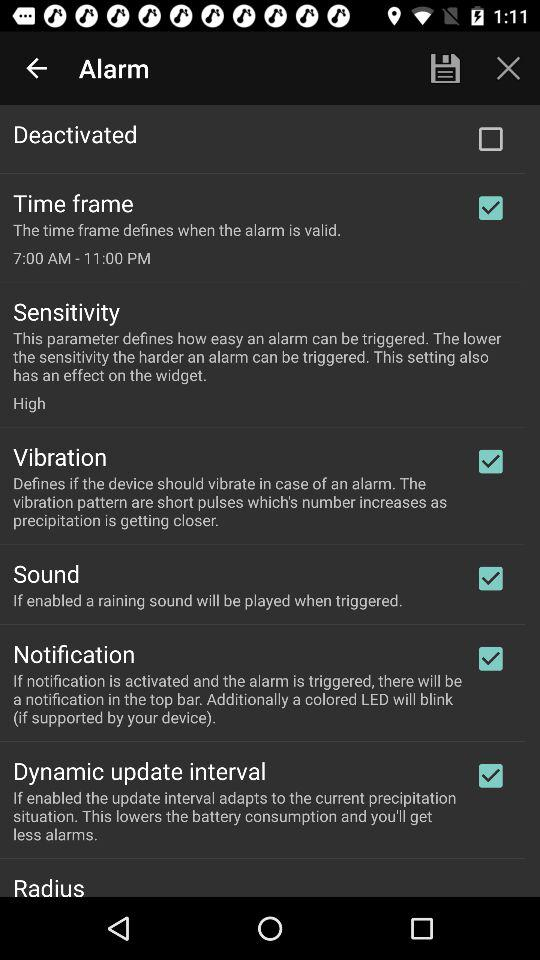What is the time frame for an alarm? The time frame is 7:00 AM - 11:00 PM. 